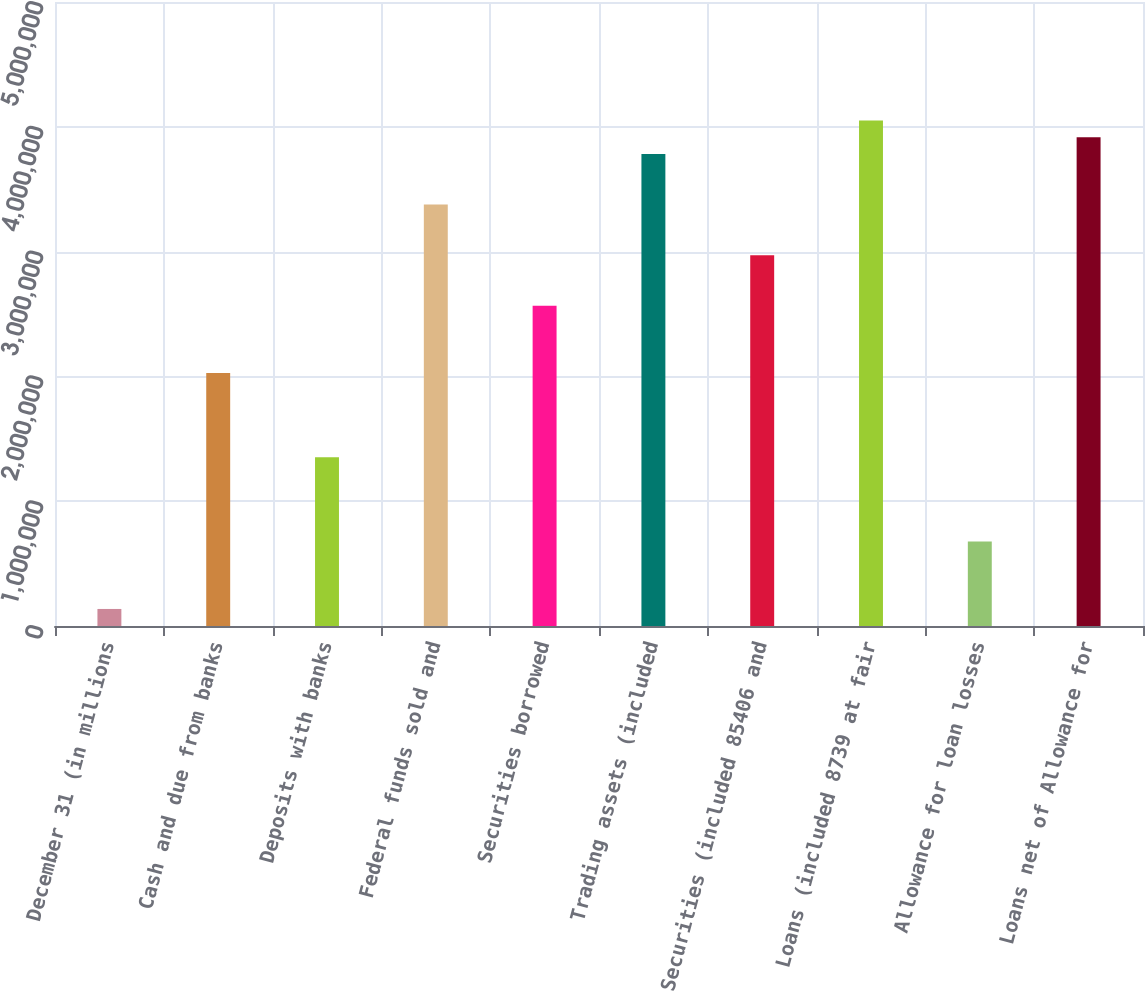<chart> <loc_0><loc_0><loc_500><loc_500><bar_chart><fcel>December 31 (in millions<fcel>Cash and due from banks<fcel>Deposits with banks<fcel>Federal funds sold and<fcel>Securities borrowed<fcel>Trading assets (included<fcel>Securities (included 85406 and<fcel>Loans (included 8739 at fair<fcel>Allowance for loan losses<fcel>Loans net of Allowance for<nl><fcel>136553<fcel>2.0265e+06<fcel>1.35152e+06<fcel>3.37646e+06<fcel>2.56649e+06<fcel>3.78145e+06<fcel>2.97148e+06<fcel>4.05145e+06<fcel>676538<fcel>3.91645e+06<nl></chart> 